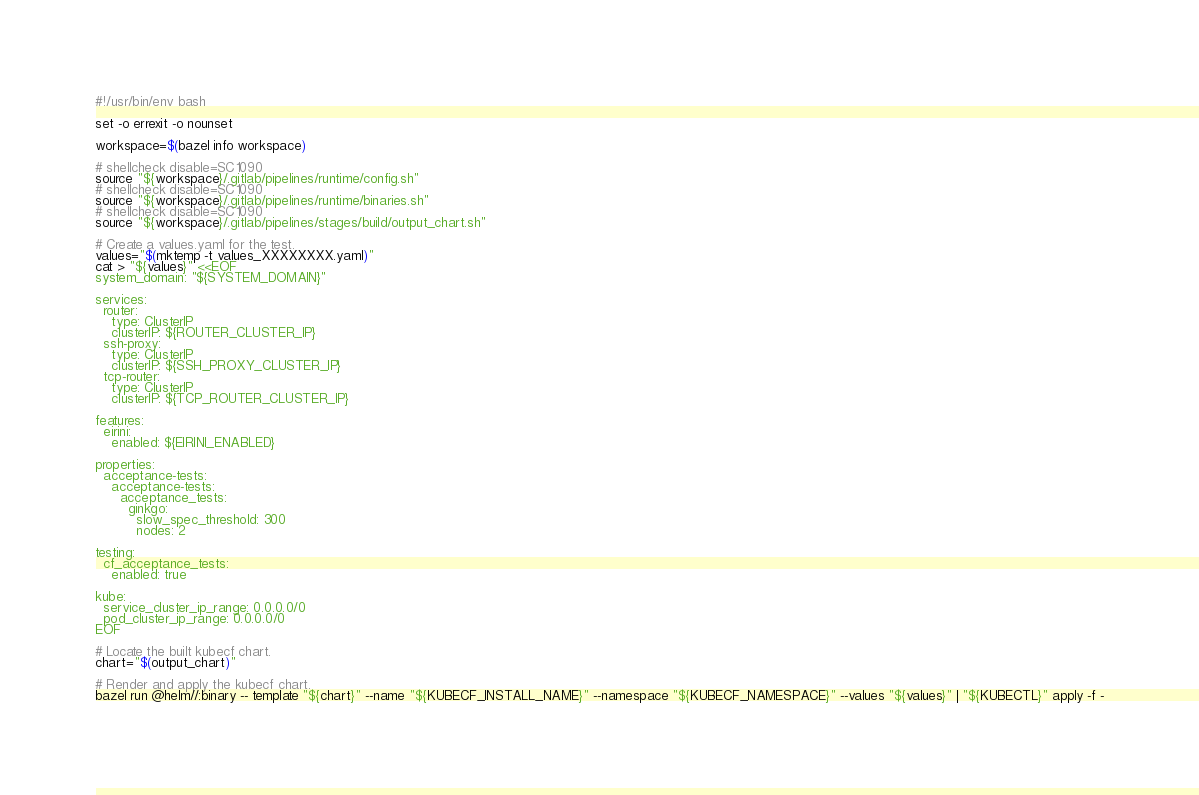Convert code to text. <code><loc_0><loc_0><loc_500><loc_500><_Bash_>#!/usr/bin/env bash

set -o errexit -o nounset

workspace=$(bazel info workspace)

# shellcheck disable=SC1090
source "${workspace}/.gitlab/pipelines/runtime/config.sh"
# shellcheck disable=SC1090
source "${workspace}/.gitlab/pipelines/runtime/binaries.sh"
# shellcheck disable=SC1090
source "${workspace}/.gitlab/pipelines/stages/build/output_chart.sh"

# Create a values.yaml for the test.
values="$(mktemp -t values_XXXXXXXX.yaml)"
cat > "${values}" <<EOF
system_domain: "${SYSTEM_DOMAIN}"

services:
  router:
    type: ClusterIP
    clusterIP: ${ROUTER_CLUSTER_IP}
  ssh-proxy:
    type: ClusterIP
    clusterIP: ${SSH_PROXY_CLUSTER_IP}
  tcp-router:
    type: ClusterIP
    clusterIP: ${TCP_ROUTER_CLUSTER_IP}

features:
  eirini:
    enabled: ${EIRINI_ENABLED}

properties:
  acceptance-tests:
    acceptance-tests:
      acceptance_tests:
        ginkgo:
          slow_spec_threshold: 300
          nodes: 2

testing:
  cf_acceptance_tests:
    enabled: true

kube:
  service_cluster_ip_range: 0.0.0.0/0
  pod_cluster_ip_range: 0.0.0.0/0
EOF

# Locate the built kubecf chart.
chart="$(output_chart)"

# Render and apply the kubecf chart.
bazel run @helm//:binary -- template "${chart}" --name "${KUBECF_INSTALL_NAME}" --namespace "${KUBECF_NAMESPACE}" --values "${values}" | "${KUBECTL}" apply -f -
</code> 